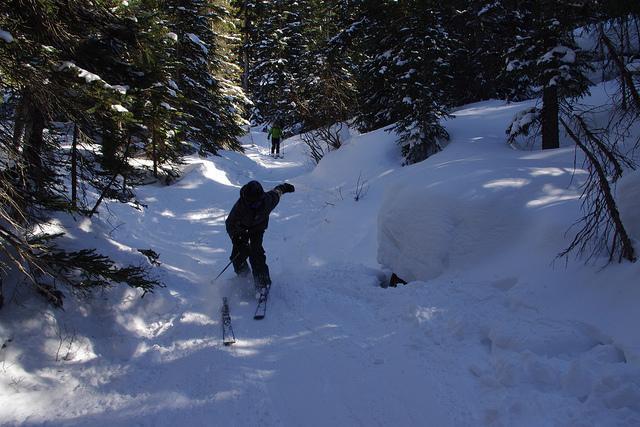How many buses are there?
Give a very brief answer. 0. 